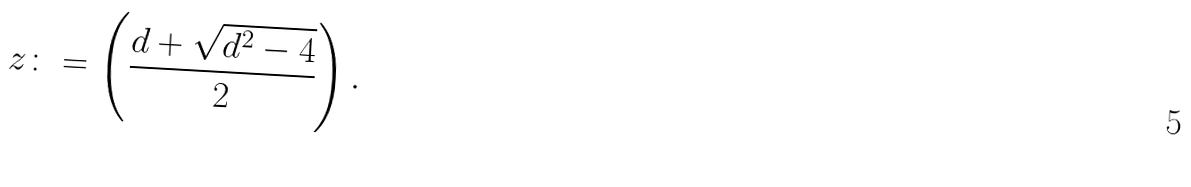<formula> <loc_0><loc_0><loc_500><loc_500>z \colon = \left ( { \frac { d + \sqrt { d ^ { 2 } - 4 } } 2 } \right ) .</formula> 